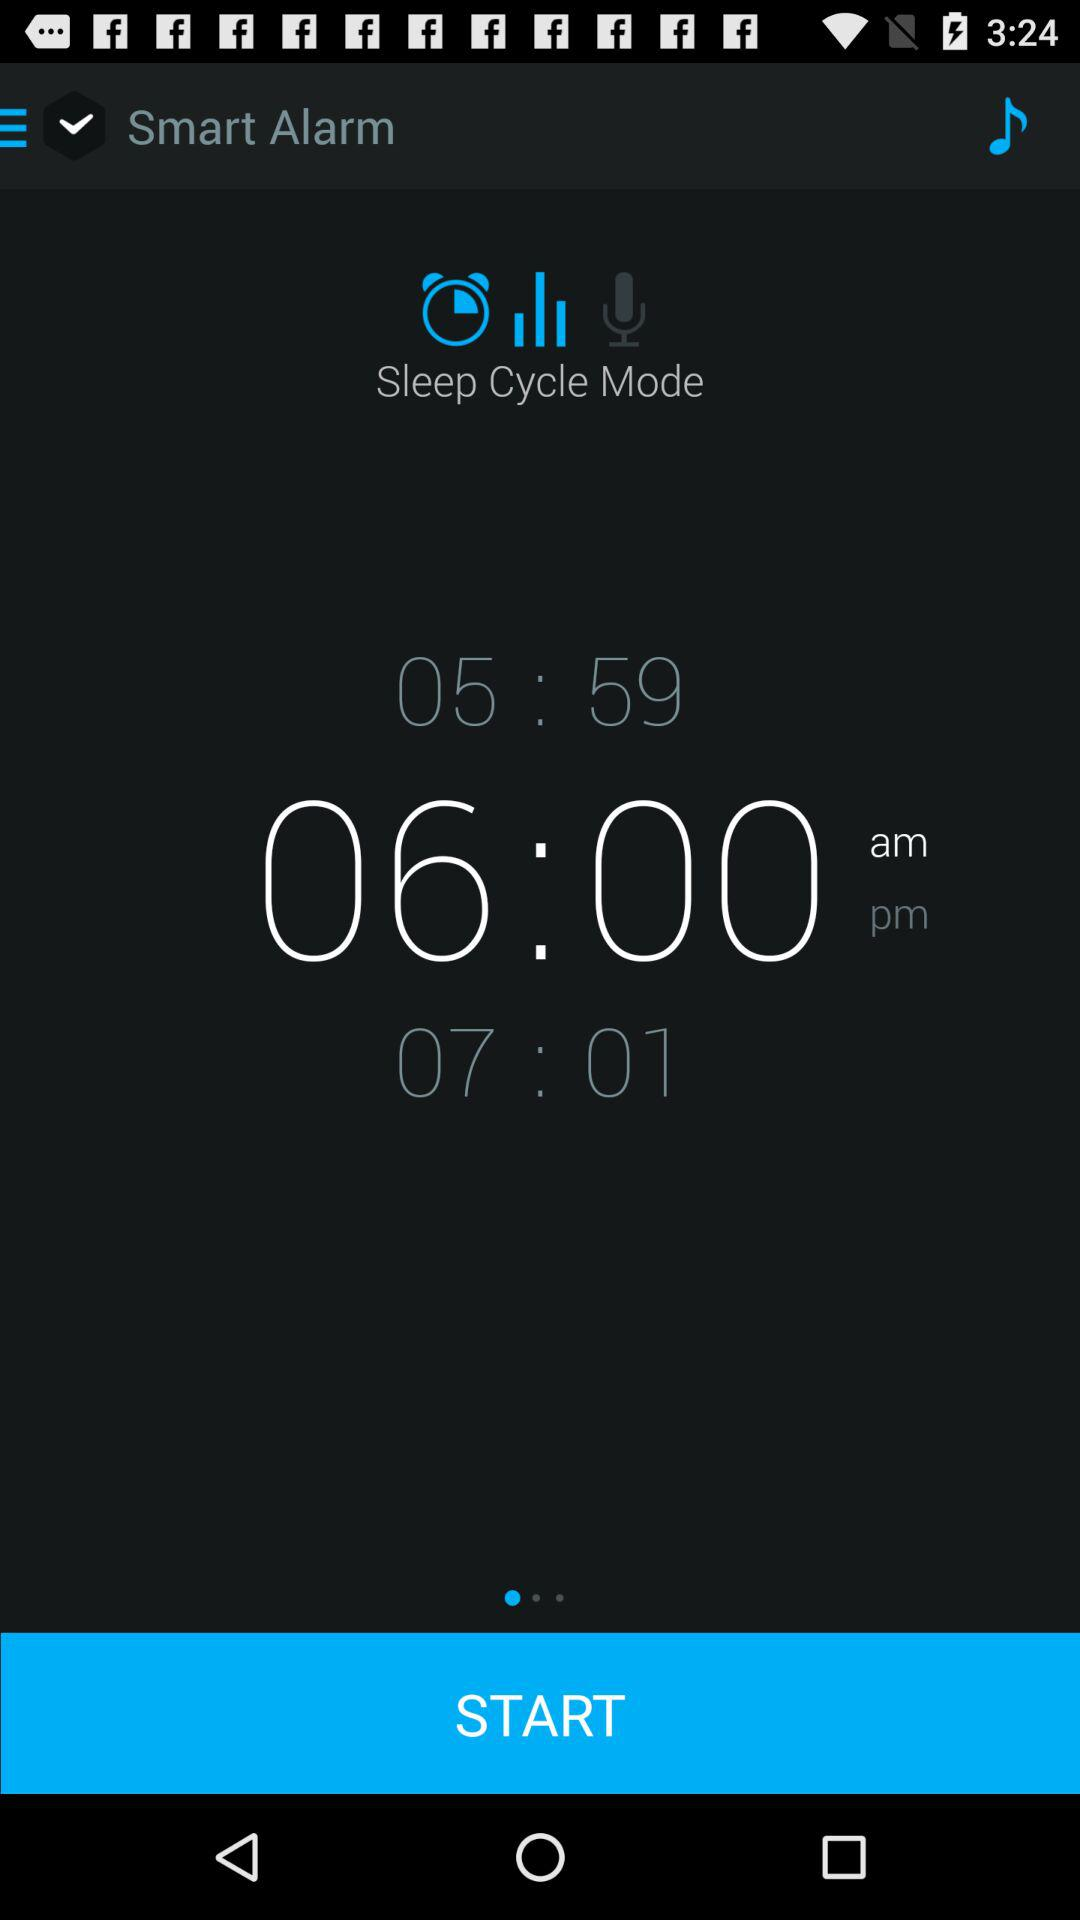What is the name of the application? The name of the application is "Smart Alarm". 